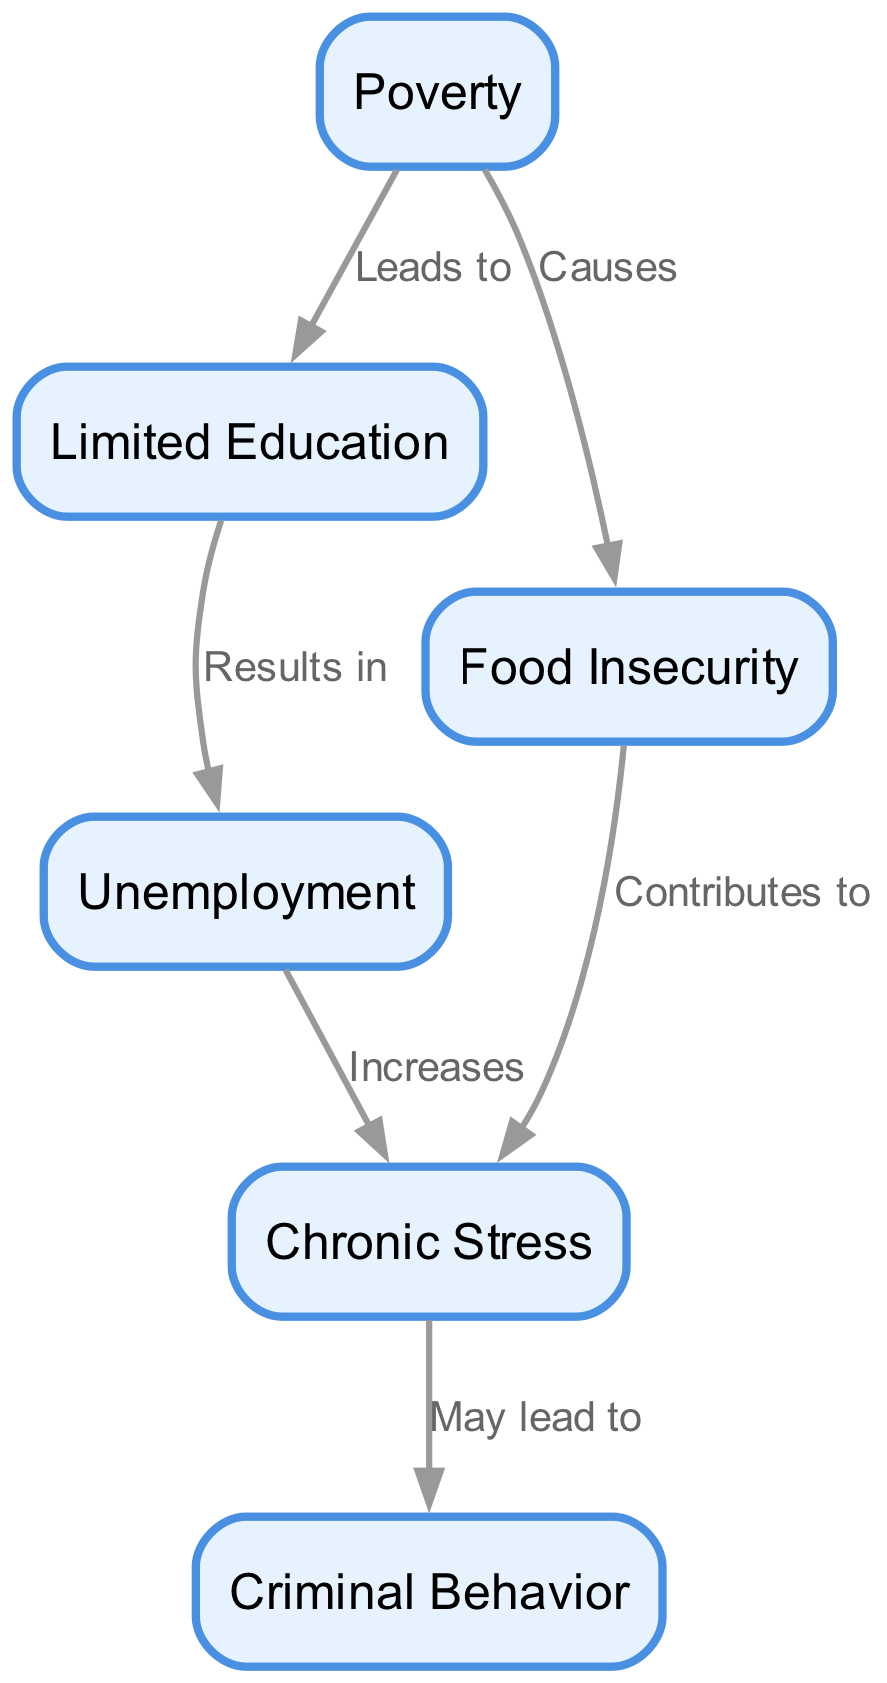What is the total number of nodes in the diagram? The diagram lists six distinct nodes: Poverty, Limited Education, Unemployment, Food Insecurity, Chronic Stress, and Criminal Behavior. Therefore, counting each of them gives a total of six nodes.
Answer: 6 Which two nodes does "Poverty" lead to? The diagram shows that "Poverty" leads to "Limited Education" and "Food Insecurity." These connections are indicated by the edges that start from the "Poverty" node.
Answer: Limited Education, Food Insecurity What results from "Limited Education"? According to the diagram, "Limited Education" results in "Unemployment." This relationship is defined by the directed edge connecting the two nodes.
Answer: Unemployment How does "Food Insecurity" affect "Chronic Stress"? The diagram states that "Food Insecurity" contributes to "Chronic Stress." This indicates a direct relationship where one influences the other in a significant way.
Answer: Contributes to What is the relationship between "Stress" and "Criminal Behavior"? The diagram indicates that "Chronic Stress" may lead to "Criminal Behavior." This relationship shows a potential outcome of the stress stemming from other factors in the food chain.
Answer: May lead to If "Unemployment" increases, what effect does it have on "Stress"? The diagram shows that "Unemployment" increases "Chronic Stress." This indicates that an increase in unemployment is directly associated with an increase in stress levels.
Answer: Increases How many edges are there in the diagram? By examining the diagram, we see five directed edges connecting the nodes. Each edge represents a relationship, thus totaling five edges in the entire diagram.
Answer: 5 Which node causes "Food Insecurity"? The diagram states that "Poverty" causes "Food Insecurity." This relationship is depicted by the directed edge that flows from the "Poverty" node to the "Food Insecurity" node.
Answer: Causes What is the chain of influence from "Poverty" to "Criminal Behavior"? Starting from "Poverty," it leads to "Limited Education" (which leads to "Unemployment"), and at the same time "Poverty" causes "Food Insecurity." Both "Unemployment" and "Food Insecurity" contribute to "Chronic Stress," which may lead to "Criminal Behavior." This chain illustrates the complexity of socio-economic factors.
Answer: Poverty → Limited Education → Unemployment → Chronic Stress → Criminal Behavior & Poverty → Food Insecurity → Chronic Stress → Criminal Behavior 